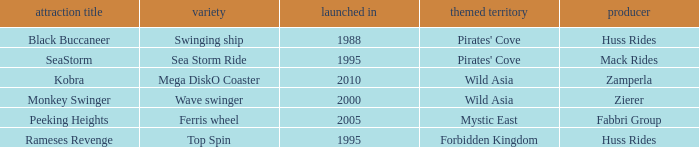Would you be able to parse every entry in this table? {'header': ['attraction title', 'variety', 'launched in', 'themed territory', 'producer'], 'rows': [['Black Buccaneer', 'Swinging ship', '1988', "Pirates' Cove", 'Huss Rides'], ['SeaStorm', 'Sea Storm Ride', '1995', "Pirates' Cove", 'Mack Rides'], ['Kobra', 'Mega DiskO Coaster', '2010', 'Wild Asia', 'Zamperla'], ['Monkey Swinger', 'Wave swinger', '2000', 'Wild Asia', 'Zierer'], ['Peeking Heights', 'Ferris wheel', '2005', 'Mystic East', 'Fabbri Group'], ['Rameses Revenge', 'Top Spin', '1995', 'Forbidden Kingdom', 'Huss Rides']]} Which ride opened after the 2000 Peeking Heights? Ferris wheel. 